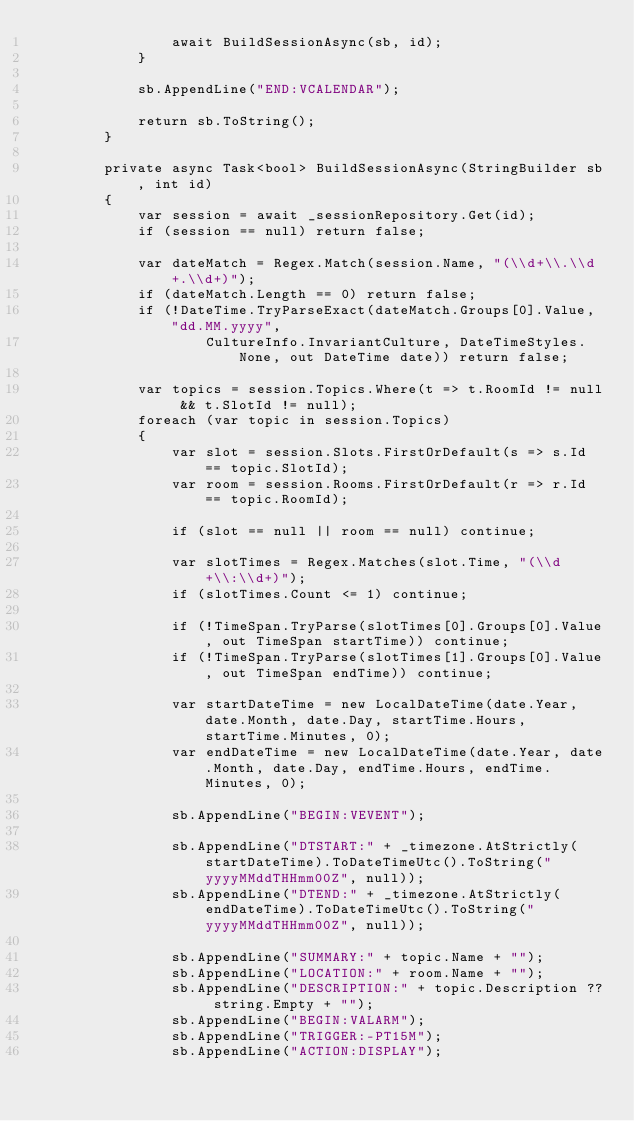Convert code to text. <code><loc_0><loc_0><loc_500><loc_500><_C#_>                await BuildSessionAsync(sb, id);
            }

            sb.AppendLine("END:VCALENDAR");

            return sb.ToString();
        }

        private async Task<bool> BuildSessionAsync(StringBuilder sb, int id)
        {
            var session = await _sessionRepository.Get(id);
            if (session == null) return false;

            var dateMatch = Regex.Match(session.Name, "(\\d+\\.\\d+.\\d+)");
            if (dateMatch.Length == 0) return false;
            if (!DateTime.TryParseExact(dateMatch.Groups[0].Value, "dd.MM.yyyy",
                    CultureInfo.InvariantCulture, DateTimeStyles.None, out DateTime date)) return false;

            var topics = session.Topics.Where(t => t.RoomId != null && t.SlotId != null);
            foreach (var topic in session.Topics)
            {
                var slot = session.Slots.FirstOrDefault(s => s.Id == topic.SlotId);
                var room = session.Rooms.FirstOrDefault(r => r.Id == topic.RoomId);

                if (slot == null || room == null) continue;

                var slotTimes = Regex.Matches(slot.Time, "(\\d+\\:\\d+)");
                if (slotTimes.Count <= 1) continue;

                if (!TimeSpan.TryParse(slotTimes[0].Groups[0].Value, out TimeSpan startTime)) continue;
                if (!TimeSpan.TryParse(slotTimes[1].Groups[0].Value, out TimeSpan endTime)) continue;

                var startDateTime = new LocalDateTime(date.Year, date.Month, date.Day, startTime.Hours, startTime.Minutes, 0);
                var endDateTime = new LocalDateTime(date.Year, date.Month, date.Day, endTime.Hours, endTime.Minutes, 0);

                sb.AppendLine("BEGIN:VEVENT");

                sb.AppendLine("DTSTART:" + _timezone.AtStrictly(startDateTime).ToDateTimeUtc().ToString("yyyyMMddTHHmm00Z", null));
                sb.AppendLine("DTEND:" + _timezone.AtStrictly(endDateTime).ToDateTimeUtc().ToString("yyyyMMddTHHmm00Z", null));

                sb.AppendLine("SUMMARY:" + topic.Name + "");
                sb.AppendLine("LOCATION:" + room.Name + "");
                sb.AppendLine("DESCRIPTION:" + topic.Description ?? string.Empty + "");
                sb.AppendLine("BEGIN:VALARM");
                sb.AppendLine("TRIGGER:-PT15M");
                sb.AppendLine("ACTION:DISPLAY");</code> 